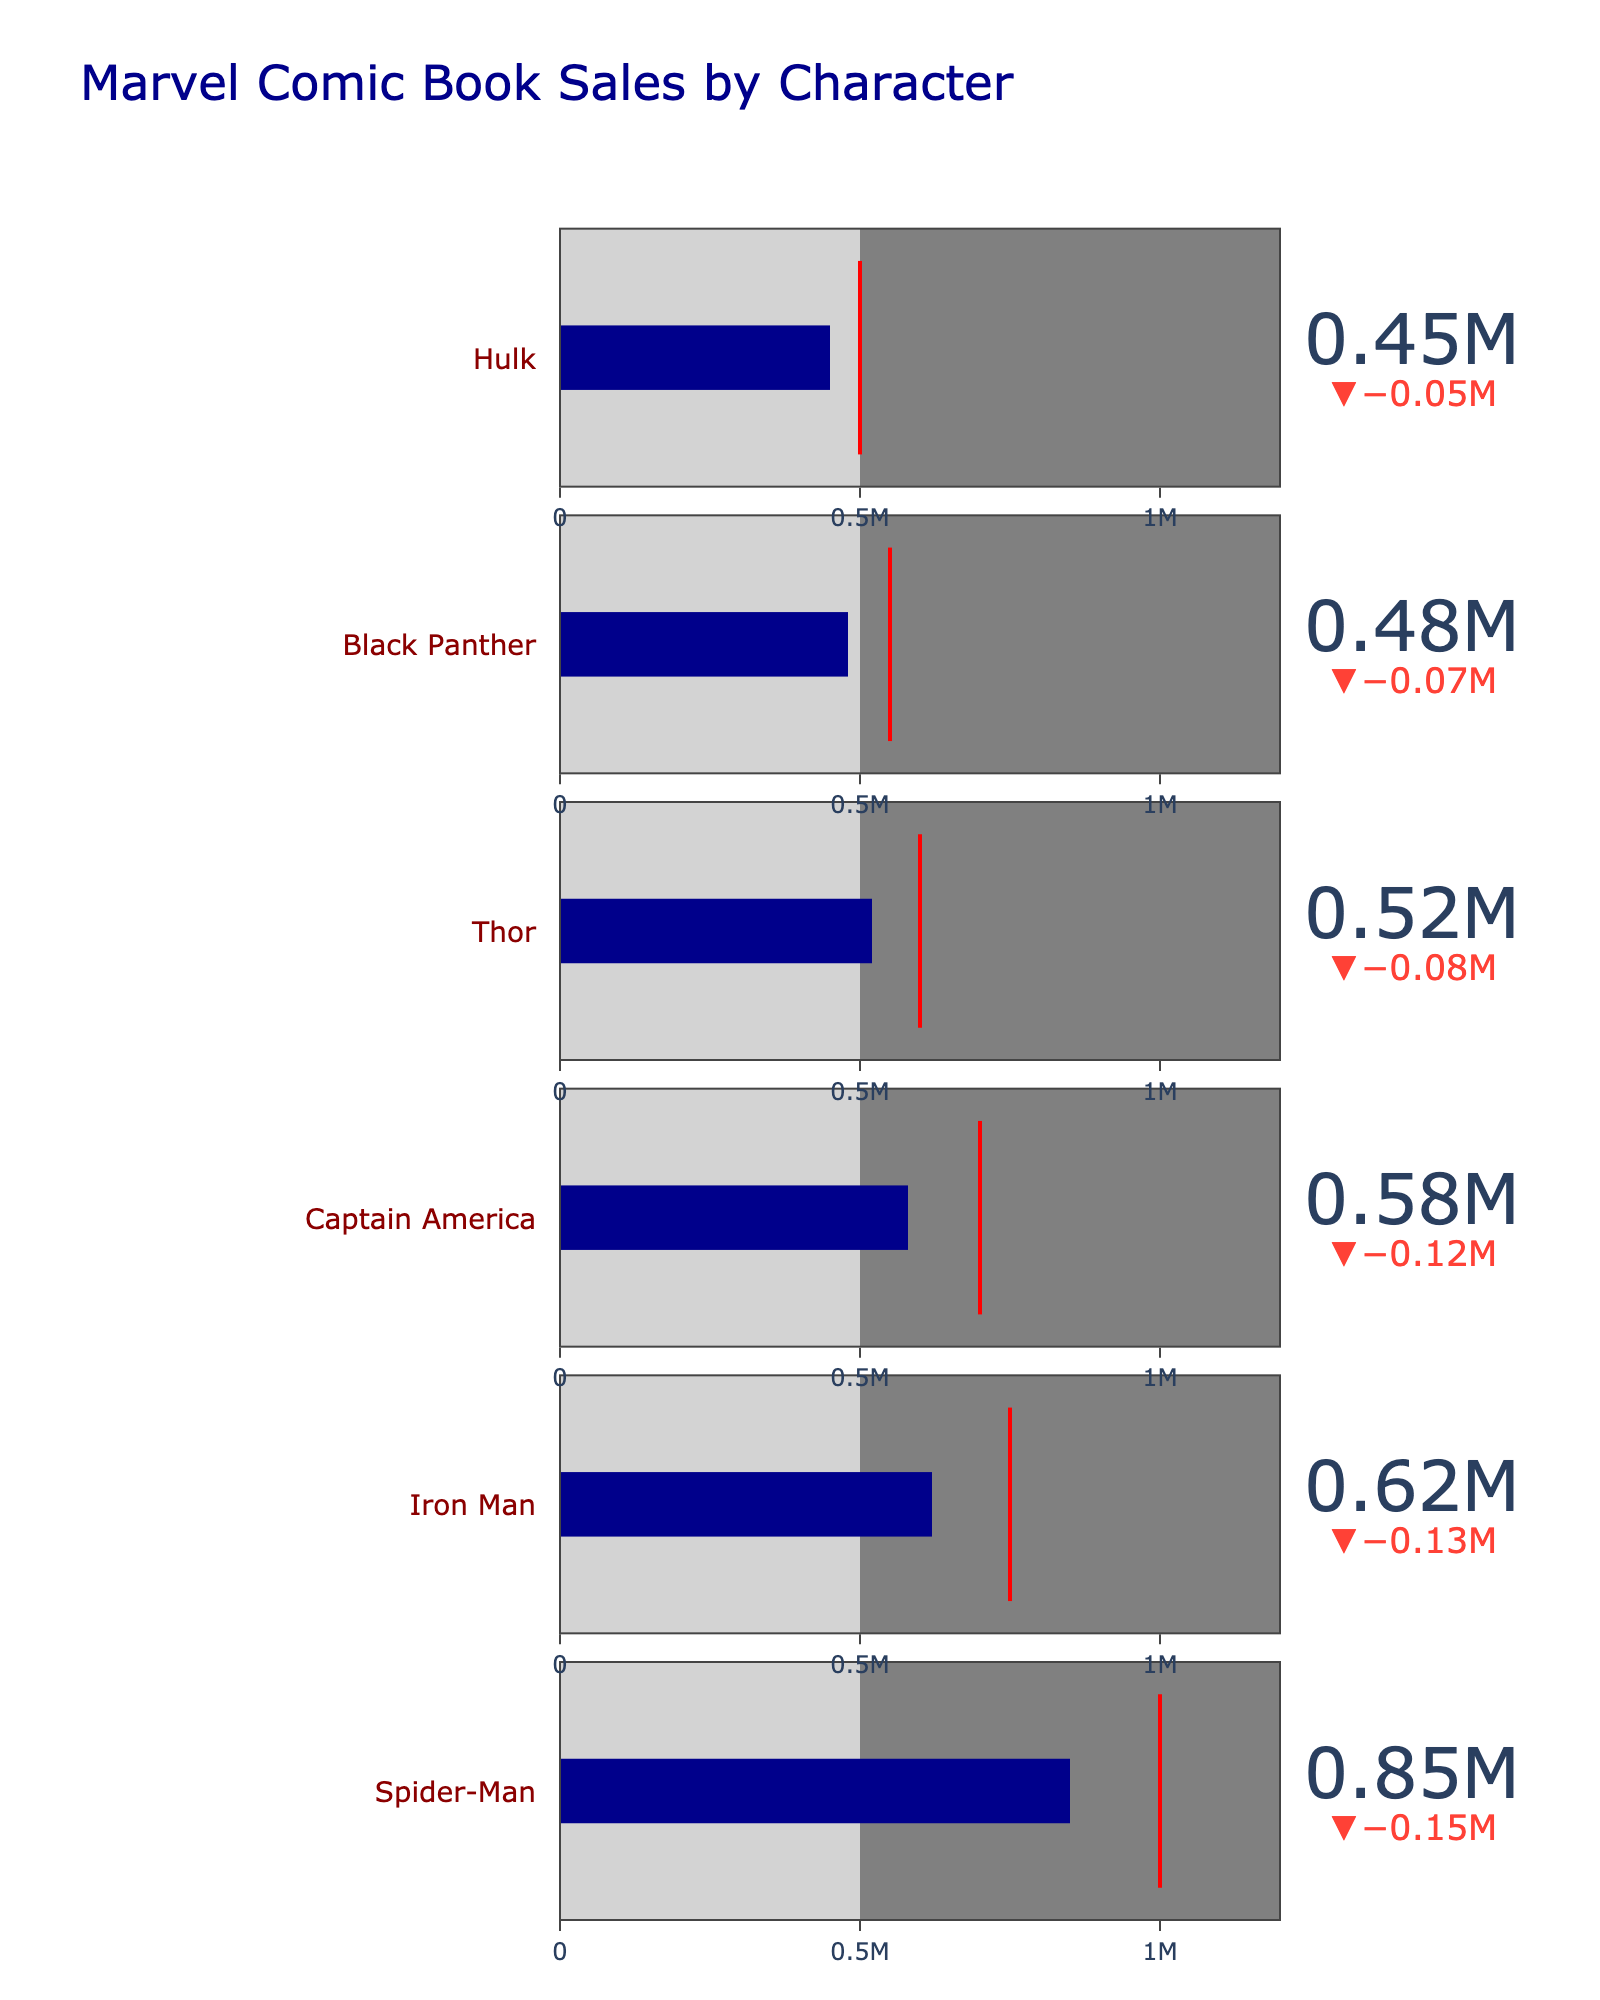What is the highest sales target for any character in the chart? The sales targets for each character are shown by the threshold line. Spider-Man has the highest target at 1,000,000.
Answer: 1,000,000 Which character has actual sales closest to the industry average? The industry average is 500,000 for all characters. The Hulk has actual sales of 450,000, which is closest to the industry average.
Answer: Hulk How much greater are Spider-Man's actual sales compared to Black Panther's? Spider-Man's actual sales are 850,000, and Black Panther's are 480,000. The difference is calculated as 850,000 - 480,000.
Answer: 370,000 Which character has the largest gap between actual sales and target sales? To determine the largest gap, subtract each character's actual sales from their target: Spider-Man (1,000,000 - 850,000), Iron Man (750,000 - 620,000), Captain America (700,000 - 580,000), Thor (600,000 - 520,000), Black Panther (550,000 - 480,000), Hulk (500,000 - 450,000). The largest gap is for Spider-Man, at 150,000.
Answer: Spider-Man Which character has actual sales that exceed the target? Comparing the actual sales to the target for each character, we see that no character has actual sales exceeding the target.
Answer: None What color represents the top performer range on the bullet chart? The top performer range is shown on the gauge by the top segment color. In this chart, it is gray.
Answer: Gray What is the difference between Iron Man's actual sales and his target sales? Iron Man's actual sales are 620,000 and his target sales are 750,000. The difference is 750,000 - 620,000.
Answer: 130,000 Which character's actual sales are furthest below the industry average? The industry average is 500,000 for all characters. The actual sales for Spider-Man, Iron Man, Captain America, Thor, Black Panther, and Hulk are 850,000, 620,000, 580,000, 520,000, 480,000, and 450,000 respectively. Hulk's 450,000 is the furthest below the industry average, at 50,000 less.
Answer: Hulk 